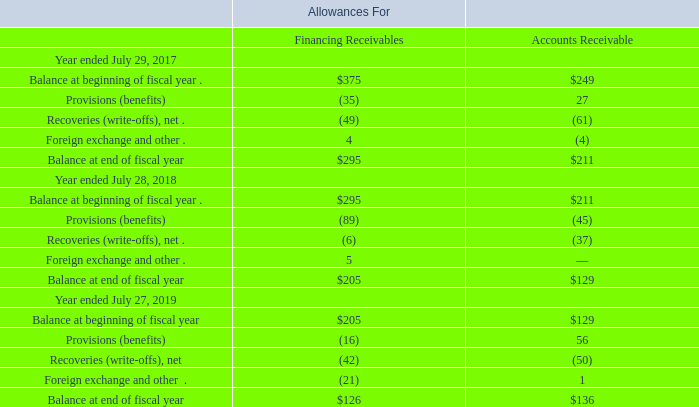VALUATION AND QUALIFYING ACCOUNTS
(in millions)
Foreign exchange and other includes the impact of foreign exchange and certain immaterial reclassifications.
What did foreign exchange and other include? The impact of foreign exchange and certain immaterial reclassifications. Which fiscal years does the table provide information for the company's valuation and qualifying accounts? 2019, 2018, 2017. What was the balance at beginning of fiscal year in 2017 for allowances for financing receivables?
Answer scale should be: million. 375. What was the change in the provisions for accounts receivables between 2017 and 2018?
Answer scale should be: million. -45-27
Answer: -72. What was the change in the Financing Receivables for Foreign exchange and other between 2017 and 2019?
Answer scale should be: million. -21-4
Answer: -25. What was the percentage change in the balance at the end of fiscal year for financing receivables between 2018 and 2019?
Answer scale should be: percent. (126-205)/205
Answer: -38.54. 